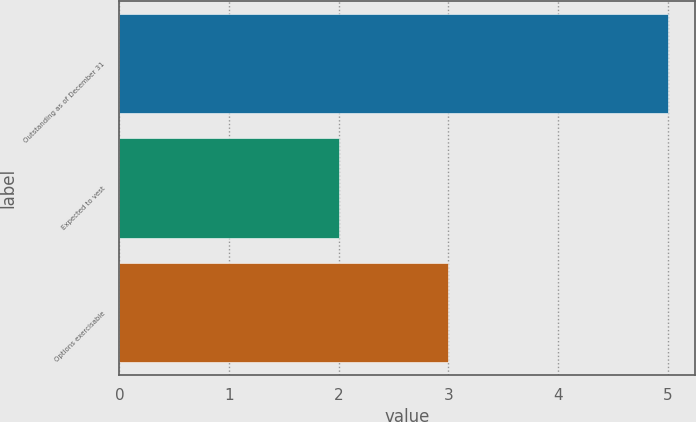Convert chart. <chart><loc_0><loc_0><loc_500><loc_500><bar_chart><fcel>Outstanding as of December 31<fcel>Expected to vest<fcel>Options exercisable<nl><fcel>5<fcel>2<fcel>3<nl></chart> 